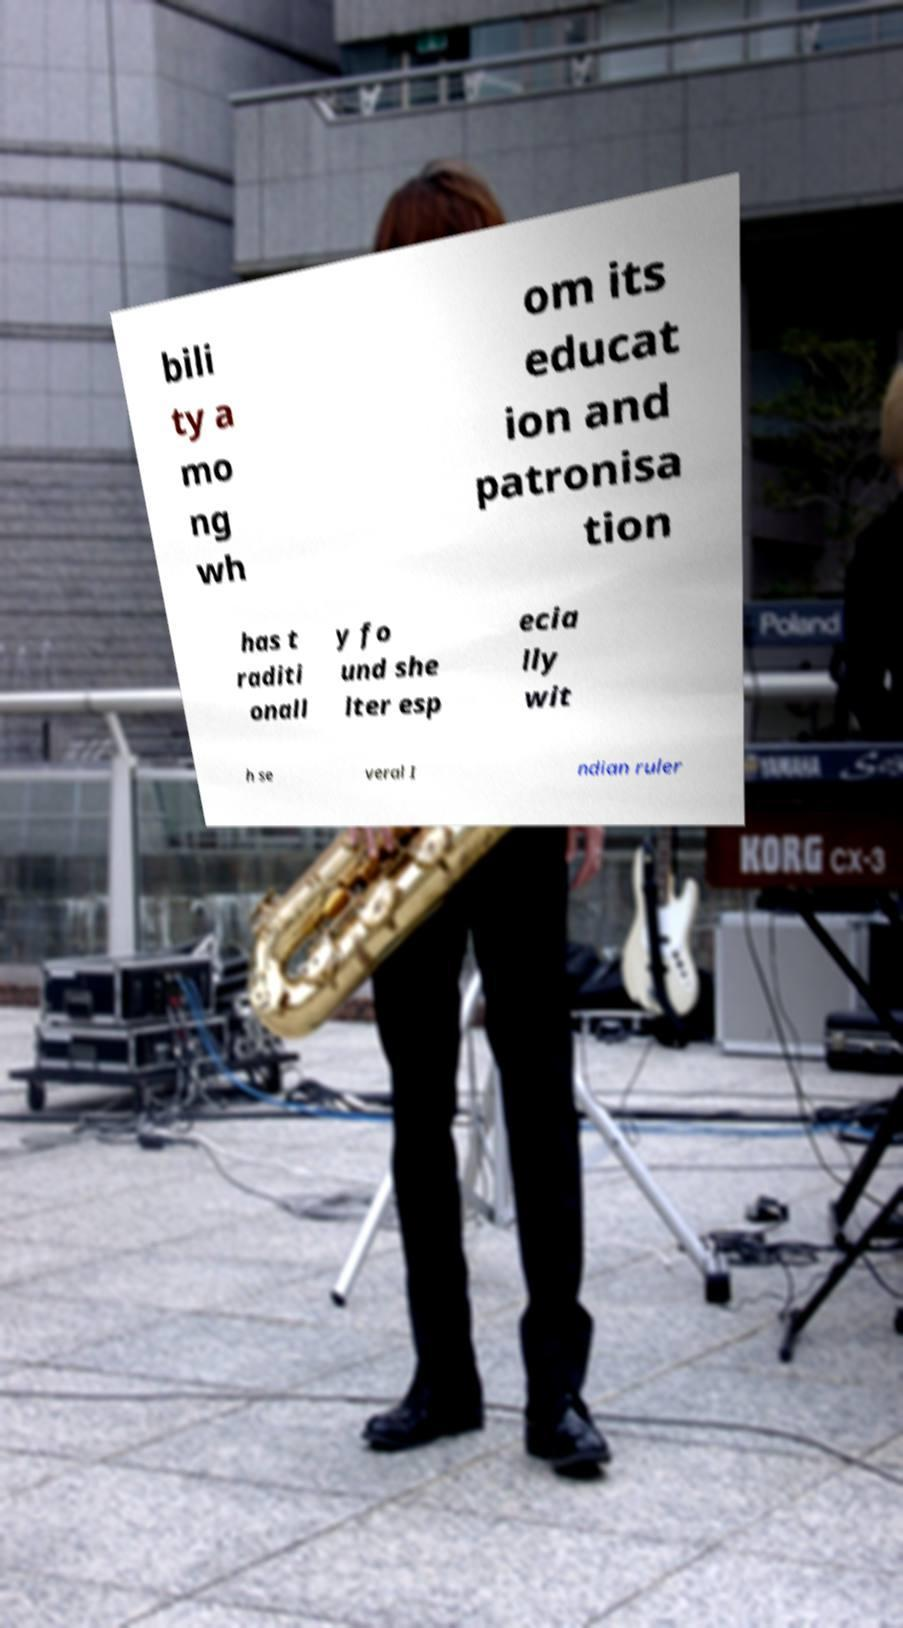For documentation purposes, I need the text within this image transcribed. Could you provide that? bili ty a mo ng wh om its educat ion and patronisa tion has t raditi onall y fo und she lter esp ecia lly wit h se veral I ndian ruler 